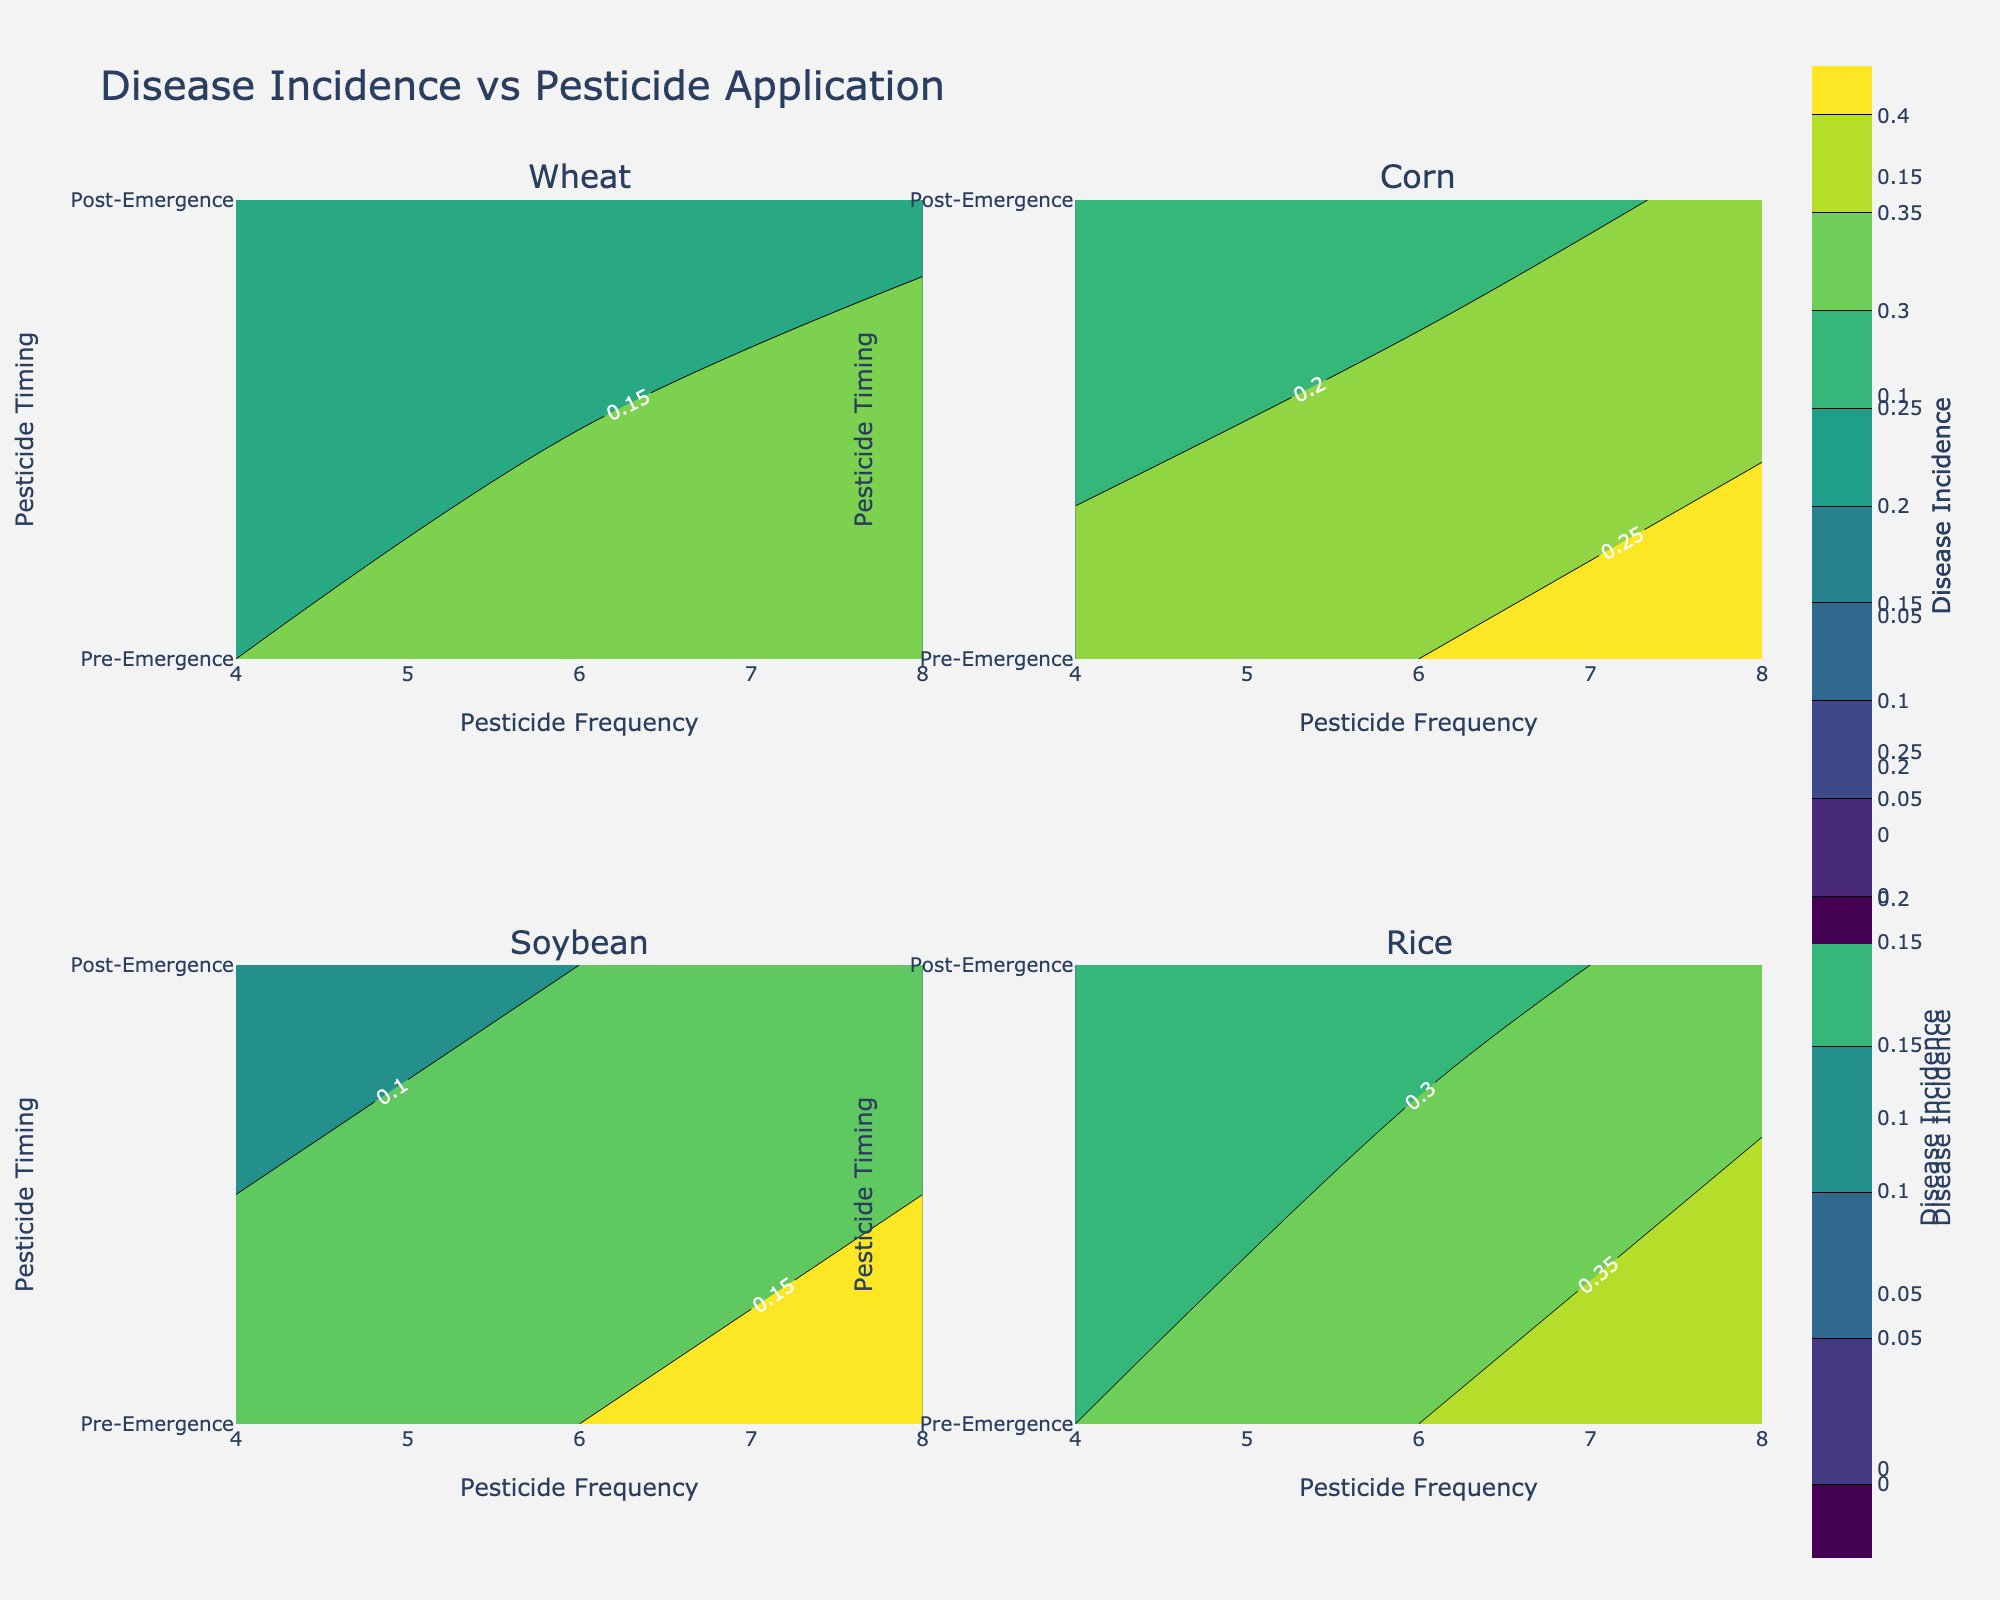What's the title of the figure? The figure's title can be found at the top of the plot. It provides a high-level summary of the visualization.
Answer: Disease Incidence vs Pesticide Application How many subplots are there in the figure? The figure utilizes a 2x2 grid layout for the subplots. Each subplot corresponds to a different crop.
Answer: Four Which pesticide application timing (Pre-Emergence or Post-Emergence) generally has higher disease incidence in Rice? By examining the contours related to Rice, note the higher concentrations of color in the Pre-Emergence timing compared to the Post-Emergence timing.
Answer: Pre-Emergence What is the range of disease incidence visualized in the contour plots? The color scale and contour levels indicate the minimum and maximum values depicted in the figures for disease incidence. The visual range is given by the contour settings from 0 to the maximum value of disease incidence in the data set.
Answer: 0 to 0.40 Which crop shows the highest disease incidence and at what pesticide frequency? Reviewing the subplot for each crop and identifying the maximum contour level can help determine the crop with the highest incidence. The highest incidence value is found in the subplot of Rice at the frequency of 8.
Answer: Rice at 8 For Wheat, is the disease incidence higher at a pesticide frequency of 6 or 8? Observing the contours for Wheat, compare the disease incidence levels indicated by the colors at frequencies 6 and 8. Locate the relative contour levels or color intensities at these points.
Answer: 8 Does Soybean show a significant difference in disease incidence between Pre-Emergence and Post-Emergence timings? Comparing the color intensities (contours) between Pre-Emergence and Post-Emergence timings for Soybean indicates that there's a noticeable but not dramatic difference in contours, denoting disease incidence.
Answer: No significant difference What visual indication is used to show the different levels of disease incidence? The contour plots use different colors to represent varying levels of disease incidence, typically ranging from lighter to darker shades (e.g., via a Viridis color scale).
Answer: Color gradients (Viridis) Which crop has the closest disease incidence levels between Pre-Emergence and Post-Emergence timings? By examining the proximity of contours in the subplots for different crops and comparing the intensities (colors) for both Pre-Emergence and Post-Emergence timings, the disease incidence levels for Soybean are quite close.
Answer: Soybean What trend is observed in disease incidence with increasing pesticide frequency for Corn? In the subplot for Corn, observe how the color intensity (disease incidence) changes as the pesticide frequency moves from lower to higher values. The trend shows an increase in disease incidence with higher frequencies.
Answer: Increasing 